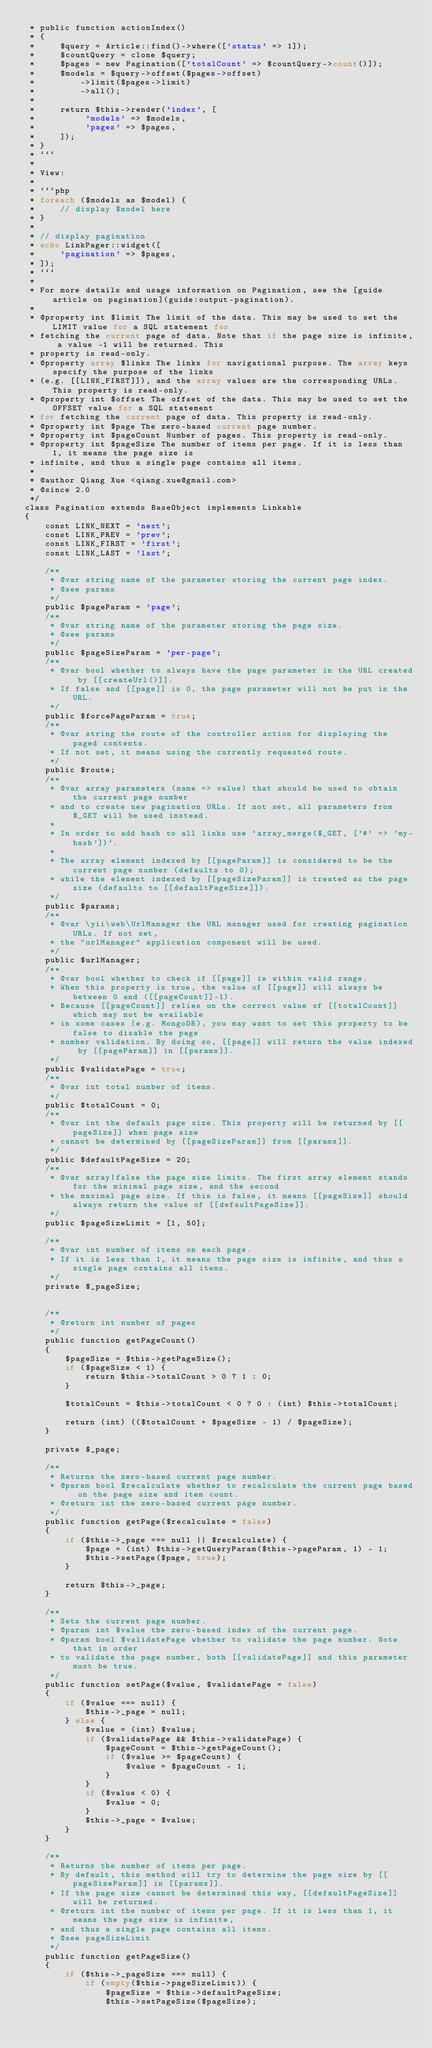<code> <loc_0><loc_0><loc_500><loc_500><_PHP_> * public function actionIndex()
 * {
 *     $query = Article::find()->where(['status' => 1]);
 *     $countQuery = clone $query;
 *     $pages = new Pagination(['totalCount' => $countQuery->count()]);
 *     $models = $query->offset($pages->offset)
 *         ->limit($pages->limit)
 *         ->all();
 *
 *     return $this->render('index', [
 *          'models' => $models,
 *          'pages' => $pages,
 *     ]);
 * }
 * ```
 *
 * View:
 *
 * ```php
 * foreach ($models as $model) {
 *     // display $model here
 * }
 *
 * // display pagination
 * echo LinkPager::widget([
 *     'pagination' => $pages,
 * ]);
 * ```
 *
 * For more details and usage information on Pagination, see the [guide article on pagination](guide:output-pagination).
 *
 * @property int $limit The limit of the data. This may be used to set the LIMIT value for a SQL statement for
 * fetching the current page of data. Note that if the page size is infinite, a value -1 will be returned. This
 * property is read-only.
 * @property array $links The links for navigational purpose. The array keys specify the purpose of the links
 * (e.g. [[LINK_FIRST]]), and the array values are the corresponding URLs. This property is read-only.
 * @property int $offset The offset of the data. This may be used to set the OFFSET value for a SQL statement
 * for fetching the current page of data. This property is read-only.
 * @property int $page The zero-based current page number.
 * @property int $pageCount Number of pages. This property is read-only.
 * @property int $pageSize The number of items per page. If it is less than 1, it means the page size is
 * infinite, and thus a single page contains all items.
 *
 * @author Qiang Xue <qiang.xue@gmail.com>
 * @since 2.0
 */
class Pagination extends BaseObject implements Linkable
{
    const LINK_NEXT = 'next';
    const LINK_PREV = 'prev';
    const LINK_FIRST = 'first';
    const LINK_LAST = 'last';

    /**
     * @var string name of the parameter storing the current page index.
     * @see params
     */
    public $pageParam = 'page';
    /**
     * @var string name of the parameter storing the page size.
     * @see params
     */
    public $pageSizeParam = 'per-page';
    /**
     * @var bool whether to always have the page parameter in the URL created by [[createUrl()]].
     * If false and [[page]] is 0, the page parameter will not be put in the URL.
     */
    public $forcePageParam = true;
    /**
     * @var string the route of the controller action for displaying the paged contents.
     * If not set, it means using the currently requested route.
     */
    public $route;
    /**
     * @var array parameters (name => value) that should be used to obtain the current page number
     * and to create new pagination URLs. If not set, all parameters from $_GET will be used instead.
     *
     * In order to add hash to all links use `array_merge($_GET, ['#' => 'my-hash'])`.
     *
     * The array element indexed by [[pageParam]] is considered to be the current page number (defaults to 0);
     * while the element indexed by [[pageSizeParam]] is treated as the page size (defaults to [[defaultPageSize]]).
     */
    public $params;
    /**
     * @var \yii\web\UrlManager the URL manager used for creating pagination URLs. If not set,
     * the "urlManager" application component will be used.
     */
    public $urlManager;
    /**
     * @var bool whether to check if [[page]] is within valid range.
     * When this property is true, the value of [[page]] will always be between 0 and ([[pageCount]]-1).
     * Because [[pageCount]] relies on the correct value of [[totalCount]] which may not be available
     * in some cases (e.g. MongoDB), you may want to set this property to be false to disable the page
     * number validation. By doing so, [[page]] will return the value indexed by [[pageParam]] in [[params]].
     */
    public $validatePage = true;
    /**
     * @var int total number of items.
     */
    public $totalCount = 0;
    /**
     * @var int the default page size. This property will be returned by [[pageSize]] when page size
     * cannot be determined by [[pageSizeParam]] from [[params]].
     */
    public $defaultPageSize = 20;
    /**
     * @var array|false the page size limits. The first array element stands for the minimal page size, and the second
     * the maximal page size. If this is false, it means [[pageSize]] should always return the value of [[defaultPageSize]].
     */
    public $pageSizeLimit = [1, 50];

    /**
     * @var int number of items on each page.
     * If it is less than 1, it means the page size is infinite, and thus a single page contains all items.
     */
    private $_pageSize;


    /**
     * @return int number of pages
     */
    public function getPageCount()
    {
        $pageSize = $this->getPageSize();
        if ($pageSize < 1) {
            return $this->totalCount > 0 ? 1 : 0;
        }

        $totalCount = $this->totalCount < 0 ? 0 : (int) $this->totalCount;

        return (int) (($totalCount + $pageSize - 1) / $pageSize);
    }

    private $_page;

    /**
     * Returns the zero-based current page number.
     * @param bool $recalculate whether to recalculate the current page based on the page size and item count.
     * @return int the zero-based current page number.
     */
    public function getPage($recalculate = false)
    {
        if ($this->_page === null || $recalculate) {
            $page = (int) $this->getQueryParam($this->pageParam, 1) - 1;
            $this->setPage($page, true);
        }

        return $this->_page;
    }

    /**
     * Sets the current page number.
     * @param int $value the zero-based index of the current page.
     * @param bool $validatePage whether to validate the page number. Note that in order
     * to validate the page number, both [[validatePage]] and this parameter must be true.
     */
    public function setPage($value, $validatePage = false)
    {
        if ($value === null) {
            $this->_page = null;
        } else {
            $value = (int) $value;
            if ($validatePage && $this->validatePage) {
                $pageCount = $this->getPageCount();
                if ($value >= $pageCount) {
                    $value = $pageCount - 1;
                }
            }
            if ($value < 0) {
                $value = 0;
            }
            $this->_page = $value;
        }
    }

    /**
     * Returns the number of items per page.
     * By default, this method will try to determine the page size by [[pageSizeParam]] in [[params]].
     * If the page size cannot be determined this way, [[defaultPageSize]] will be returned.
     * @return int the number of items per page. If it is less than 1, it means the page size is infinite,
     * and thus a single page contains all items.
     * @see pageSizeLimit
     */
    public function getPageSize()
    {
        if ($this->_pageSize === null) {
            if (empty($this->pageSizeLimit)) {
                $pageSize = $this->defaultPageSize;
                $this->setPageSize($pageSize);</code> 